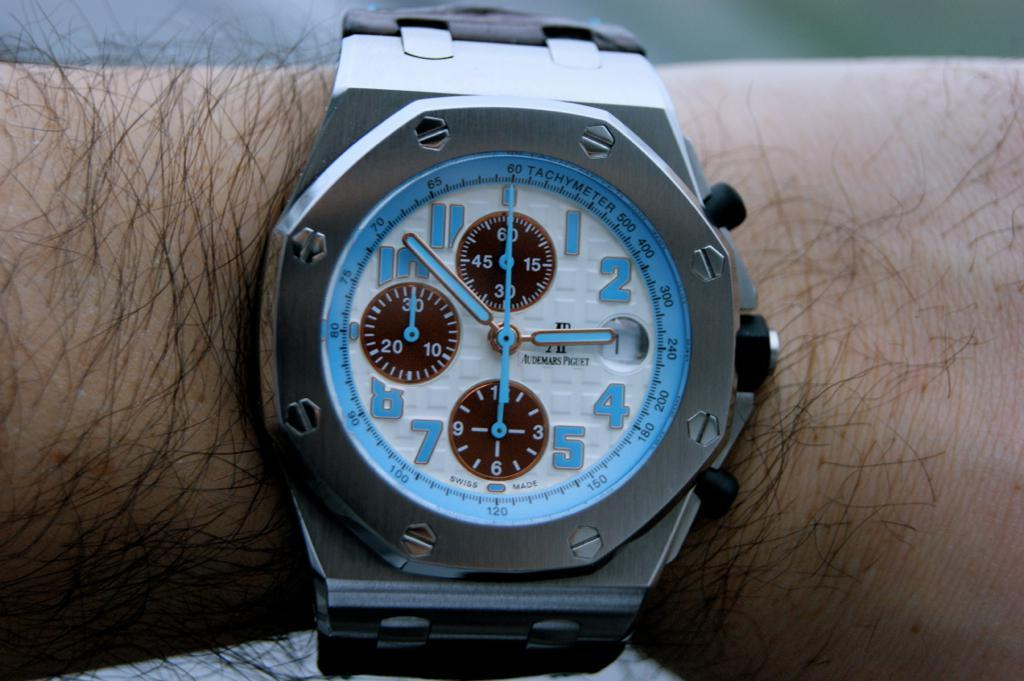Provide a one-sentence caption for the provided image. A man with a slightly hairy arm is wearing a blue and silver, Audemars Piguet wrist watch that has the time 2:52. 